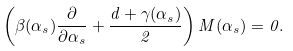<formula> <loc_0><loc_0><loc_500><loc_500>\left ( \beta ( \alpha _ { s } ) \frac { \partial } { \partial \alpha _ { s } } + \frac { d + \gamma ( \alpha _ { s } ) } { 2 } \right ) M ( \alpha _ { s } ) = 0 .</formula> 